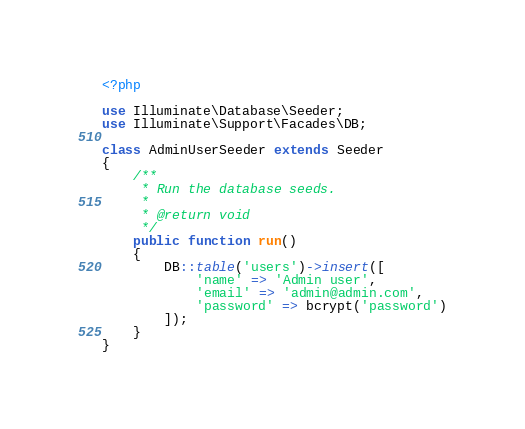<code> <loc_0><loc_0><loc_500><loc_500><_PHP_><?php

use Illuminate\Database\Seeder;
use Illuminate\Support\Facades\DB;

class AdminUserSeeder extends Seeder
{
    /**
     * Run the database seeds.
     *
     * @return void
     */
    public function run()
    {
        DB::table('users')->insert([
            'name' => 'Admin user',
            'email' => 'admin@admin.com',
            'password' => bcrypt('password')
        ]);
    }
}
</code> 